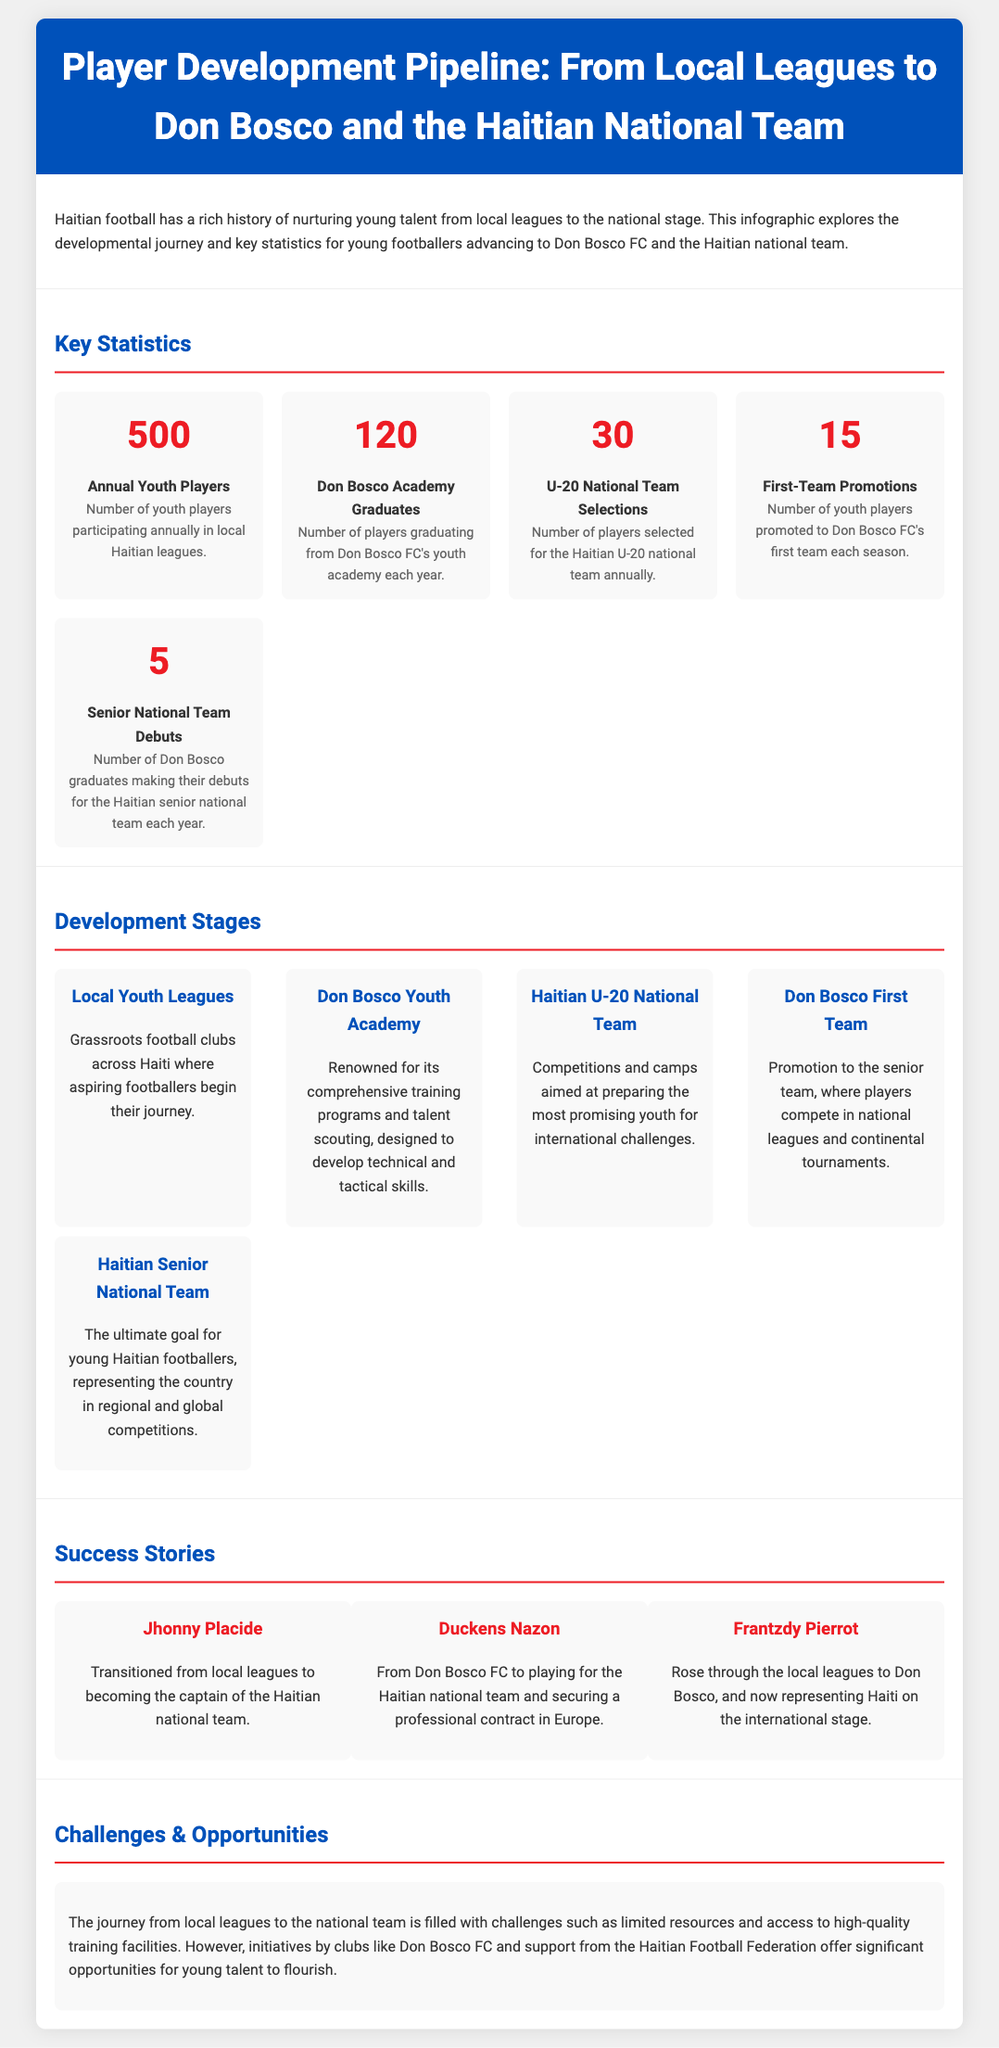What is the number of annual youth players participating in local Haitian leagues? The document states that 500 youth players participate annually in local Haitian leagues.
Answer: 500 How many players graduate from the Don Bosco Academy each year? According to the infographic, the number of players graduating from Don Bosco FC's youth academy each year is 120.
Answer: 120 What is the number of first-team promotions each season at Don Bosco FC? The document indicates that there are 15 youth players promoted to Don Bosco FC's first team each season.
Answer: 15 Who transitioned from local leagues to become the captain of the Haitian national team? The success story of Jhonny Placide highlights his transition from local leagues to becoming the captain of the Haitian national team.
Answer: Jhonny Placide What challenges do young players face on their journey to the national team? The document mentions limited resources and access to high-quality training facilities as challenges faced by young players.
Answer: Limited resources How many players are selected for the Haitian U-20 national team annually? The infographic specifies that 30 players are selected for the Haitian U-20 national team annually.
Answer: 30 What is the final stage of the player development pipeline for young Haitian footballers? The last stage outlined in the document is representing the country in regional and global competitions as part of the Haitian Senior National Team.
Answer: Haitian Senior National Team What is the significance of Don Bosco FC in player development? The infographic emphasizes Don Bosco FC's role in providing opportunities and comprehensive training for young footballers.
Answer: Comprehensive training 